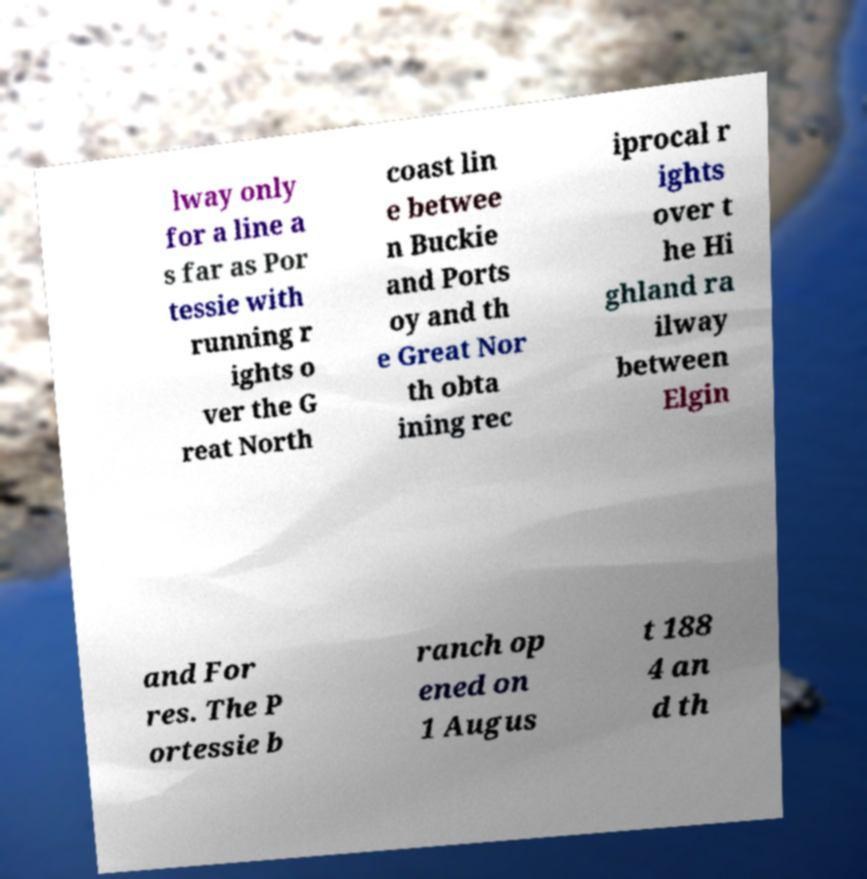Could you extract and type out the text from this image? lway only for a line a s far as Por tessie with running r ights o ver the G reat North coast lin e betwee n Buckie and Ports oy and th e Great Nor th obta ining rec iprocal r ights over t he Hi ghland ra ilway between Elgin and For res. The P ortessie b ranch op ened on 1 Augus t 188 4 an d th 